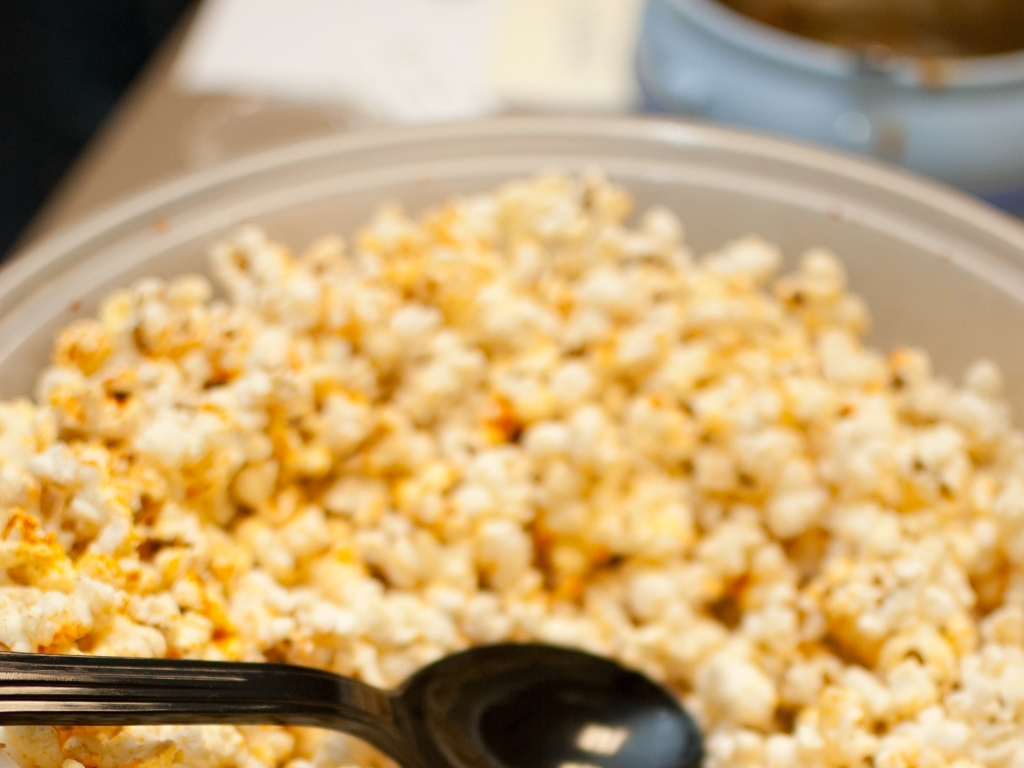What type of dish is shown in this image? The image displays a bowl of popcorn, which appears to be seasoned, possibly with a coating of cheese or spices to add flavor. 